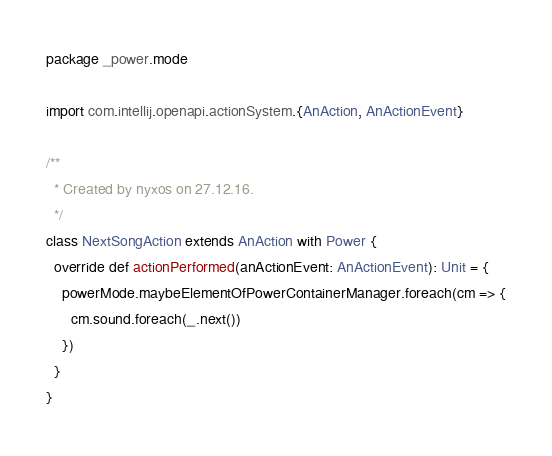Convert code to text. <code><loc_0><loc_0><loc_500><loc_500><_Scala_>package _power.mode

import com.intellij.openapi.actionSystem.{AnAction, AnActionEvent}

/**
  * Created by nyxos on 27.12.16.
  */
class NextSongAction extends AnAction with Power {
  override def actionPerformed(anActionEvent: AnActionEvent): Unit = {
    powerMode.maybeElementOfPowerContainerManager.foreach(cm => {
      cm.sound.foreach(_.next())
    })
  }
}
</code> 